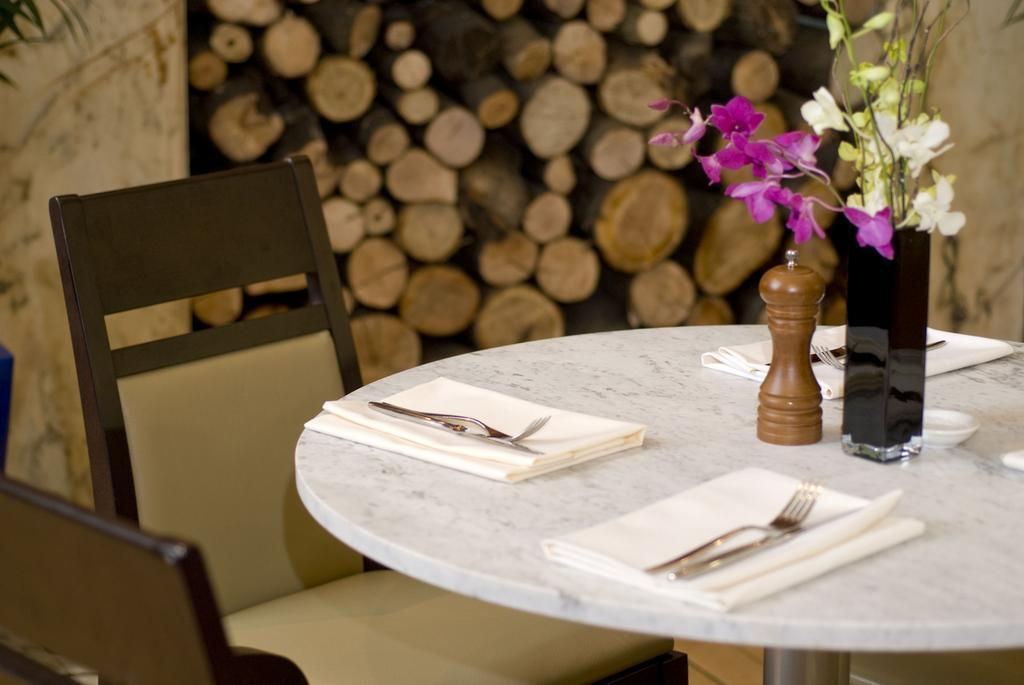What piece of furniture is present in the image? There is a table in the image. How many chairs are visible in the image? There are two chairs in the image. What decorative item is on the table? There is a flower vase on the table. How many sets of napkin, fork, and knife are on the table? There are three sets of napkin, fork, and knife on the table. How many servants are present in the image? There is no mention of servants in the image; it only features a table, chairs, a flower vase, and sets of napkin, fork, and knife. What type of kettle can be seen on the table? There is no kettle present in the image. 